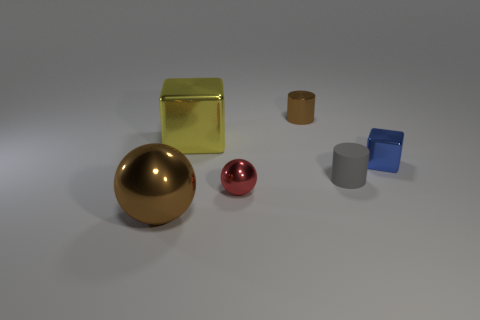Is there anything else that is the same material as the gray cylinder?
Give a very brief answer. No. There is a gray thing that is the same size as the brown cylinder; what is it made of?
Offer a very short reply. Rubber. Is there a tiny blue metallic object of the same shape as the yellow thing?
Your answer should be very brief. Yes. What shape is the big shiny object that is in front of the small matte cylinder?
Make the answer very short. Sphere. What number of yellow metal cubes are there?
Your answer should be compact. 1. The big block that is the same material as the brown ball is what color?
Make the answer very short. Yellow. What number of large objects are either gray matte objects or metallic blocks?
Provide a short and direct response. 1. There is a red thing; what number of yellow shiny objects are in front of it?
Offer a very short reply. 0. What color is the other big shiny object that is the same shape as the blue object?
Provide a succinct answer. Yellow. How many rubber objects are either tiny gray cylinders or small purple spheres?
Offer a very short reply. 1. 